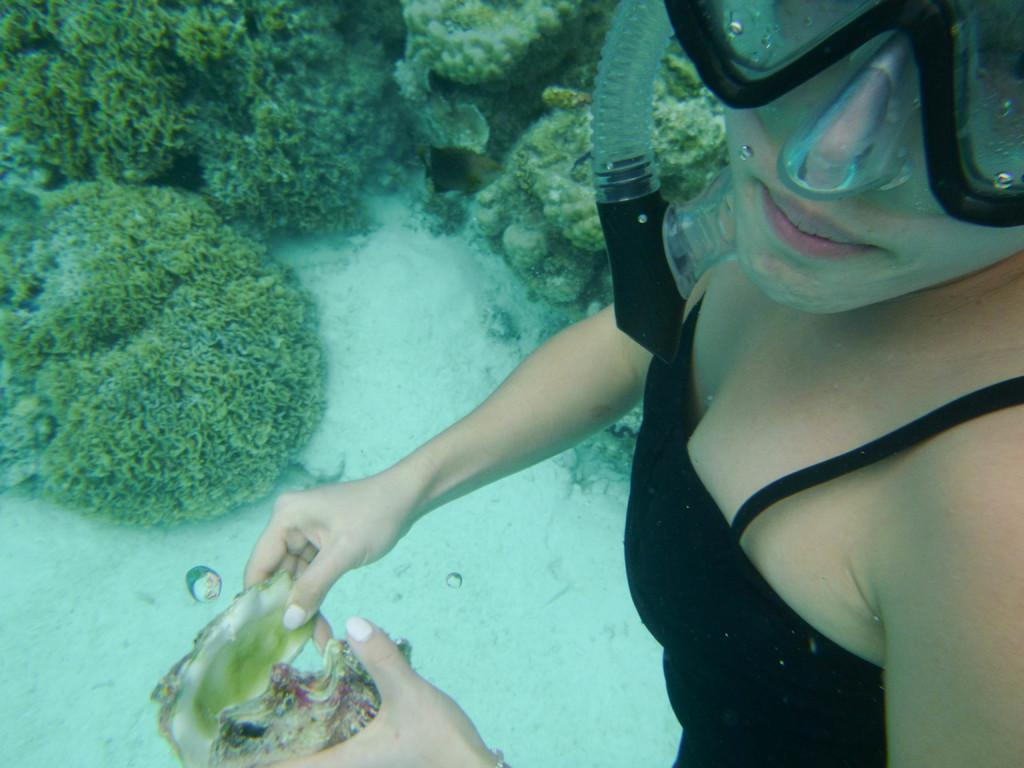Who is present in the image? There is a woman in the image. What is the woman wearing? The woman is wearing a black dress. What is the woman holding in the image? The woman is holding a shell. What can be seen at the bottom of the image? There are small plants in the water at the bottom of the image. What is the woman wearing on her face? The woman is wearing an oxygen mask. What type of stone is the woman using to unlock the door in the image? There is no stone or door present in the image. How many keys can be seen in the woman's hand in the image? The woman is not holding any keys in the image. 